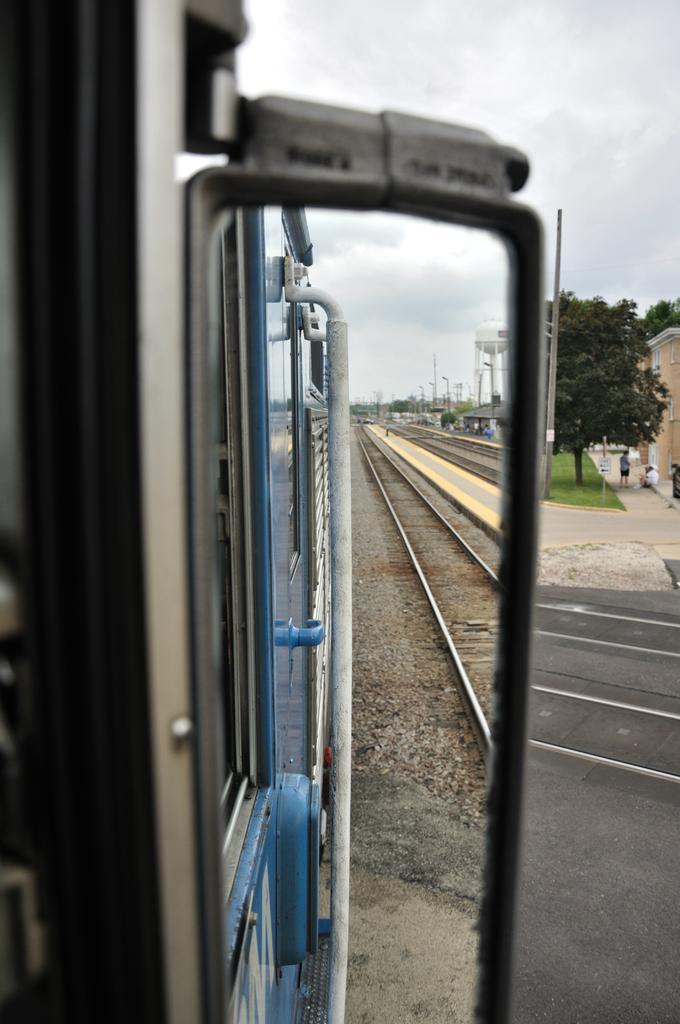Please provide a concise description of this image. In this picture, we see a train in blue color is moving on the tracks. Beside that, we see the railway tracks. On the right side, we see the platform and we see the people. Behind them, we see the tree and a board in white color. There are trees, buildings, a tower and street lights in the background. At the top, we see the sky. 